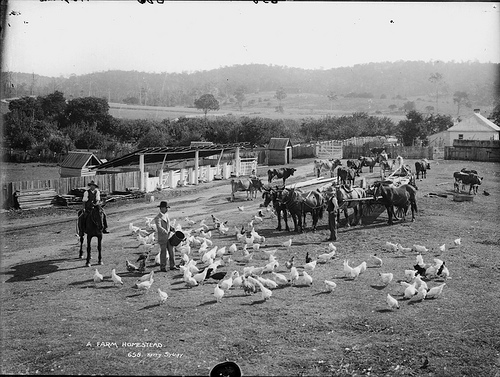Read all the text in this image. A FARM 